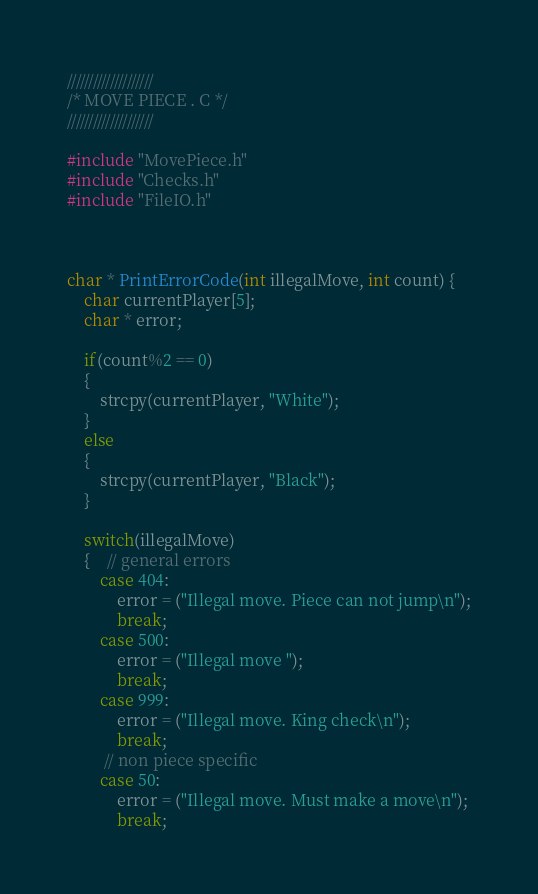<code> <loc_0><loc_0><loc_500><loc_500><_C_>
////////////////////
/* MOVE PIECE . C */
////////////////////

#include "MovePiece.h"
#include "Checks.h"
#include "FileIO.h"



char * PrintErrorCode(int illegalMove, int count) {
	char currentPlayer[5];
	char * error;

	if(count%2 == 0)
	{
		strcpy(currentPlayer, "White");
	}
	else
	{
		strcpy(currentPlayer, "Black");
	} 

	switch(illegalMove)
	{    // general errors
        case 404:
			error = ("Illegal move. Piece can not jump\n");
			break;
		case 500:
			error = ("Illegal move "); 
			break;
		case 999:
			error = ("Illegal move. King check\n");
			break;	    
	     // non piece specific  
		case 50:
			error = ("Illegal move. Must make a move\n");
			break;</code> 